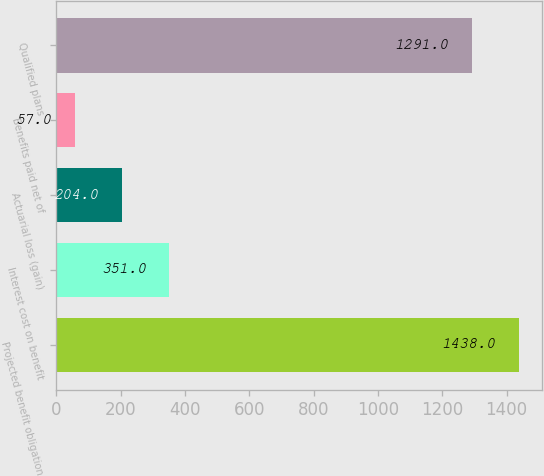Convert chart to OTSL. <chart><loc_0><loc_0><loc_500><loc_500><bar_chart><fcel>Projected benefit obligation<fcel>Interest cost on benefit<fcel>Actuarial loss (gain)<fcel>Benefits paid net of<fcel>Qualified plans<nl><fcel>1438<fcel>351<fcel>204<fcel>57<fcel>1291<nl></chart> 